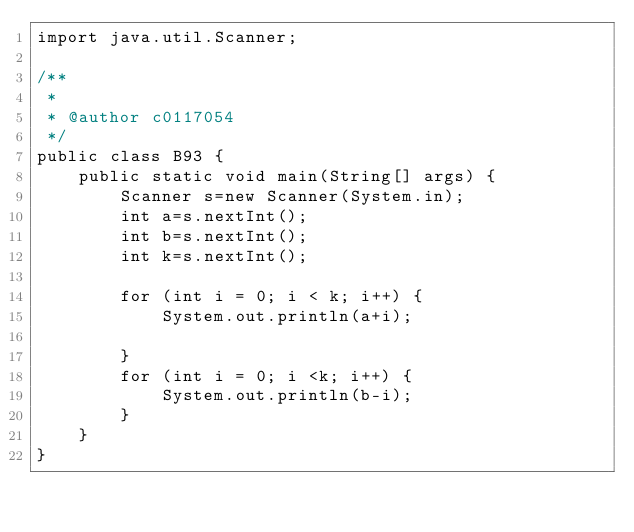<code> <loc_0><loc_0><loc_500><loc_500><_Java_>import java.util.Scanner;

/**
 *
 * @author c0117054
 */
public class B93 {
    public static void main(String[] args) {
        Scanner s=new Scanner(System.in);
        int a=s.nextInt();
        int b=s.nextInt();
        int k=s.nextInt();
        
        for (int i = 0; i < k; i++) {
            System.out.println(a+i);
            
        }
        for (int i = 0; i <k; i++) {
            System.out.println(b-i);
        }
    }
}</code> 